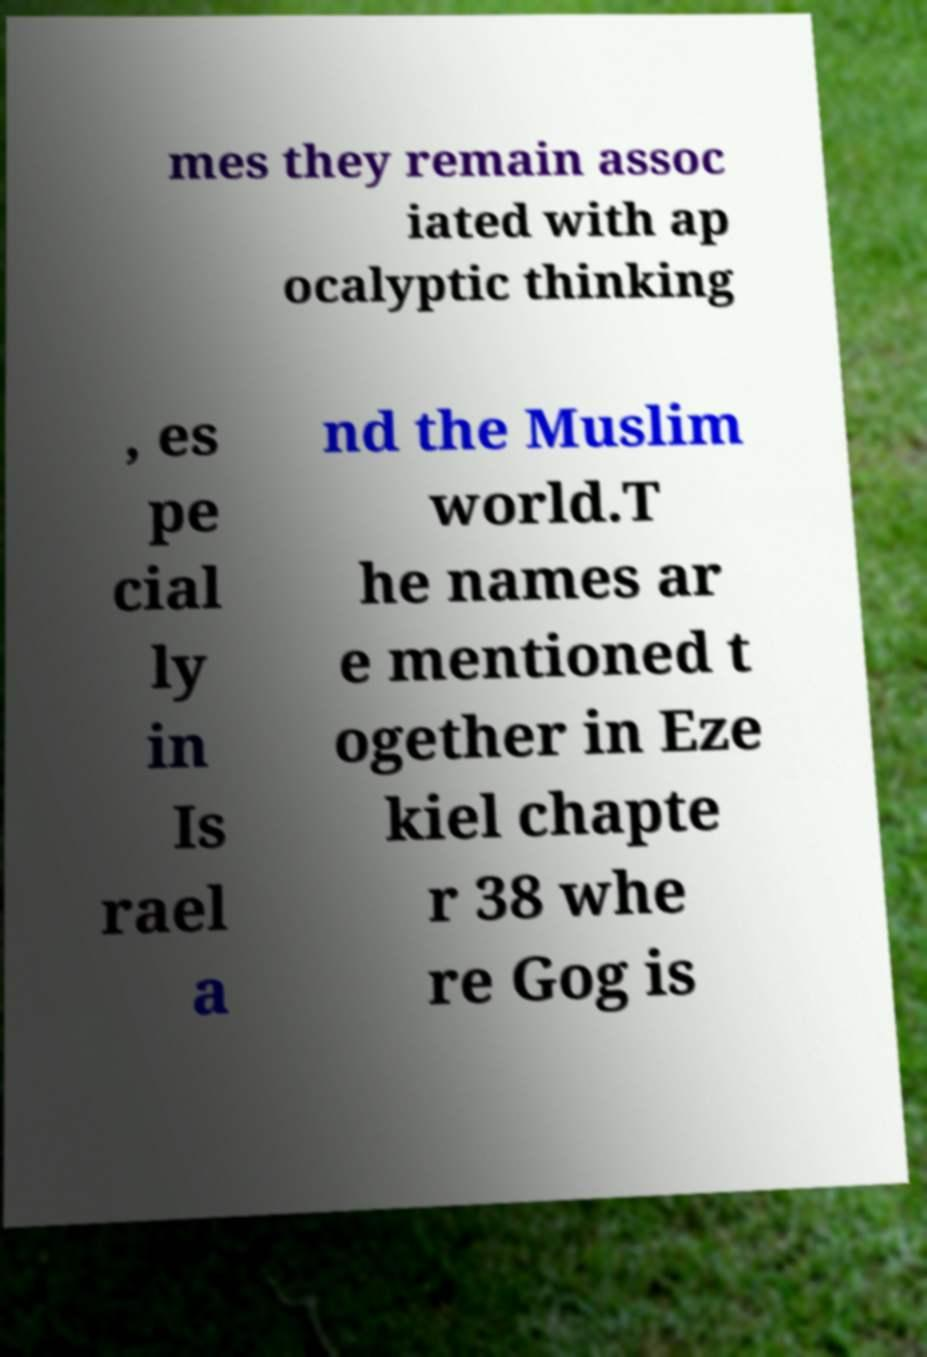What messages or text are displayed in this image? I need them in a readable, typed format. mes they remain assoc iated with ap ocalyptic thinking , es pe cial ly in Is rael a nd the Muslim world.T he names ar e mentioned t ogether in Eze kiel chapte r 38 whe re Gog is 